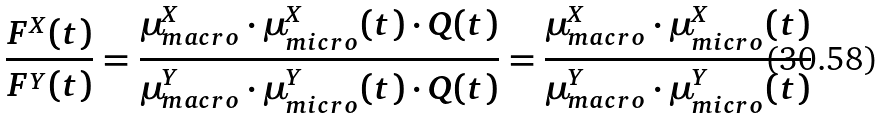<formula> <loc_0><loc_0><loc_500><loc_500>\frac { F ^ { X } ( t ) } { F ^ { Y } ( t ) } = \frac { \mu _ { m a c r o } ^ { X } \cdot \mu _ { m i c r o } ^ { X } ( t ) \cdot Q ( t ) } { \mu _ { m a c r o } ^ { Y } \cdot \mu _ { m i c r o } ^ { Y } ( t ) \cdot Q ( t ) } = \frac { \mu _ { m a c r o } ^ { X } \cdot \mu _ { m i c r o } ^ { X } ( t ) } { \mu _ { m a c r o } ^ { Y } \cdot \mu _ { m i c r o } ^ { Y } ( t ) }</formula> 